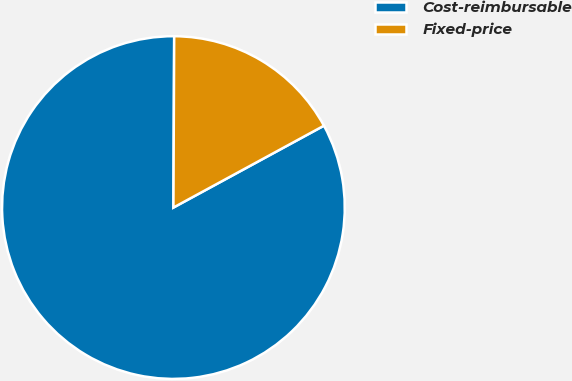<chart> <loc_0><loc_0><loc_500><loc_500><pie_chart><fcel>Cost-reimbursable<fcel>Fixed-price<nl><fcel>83.0%<fcel>17.0%<nl></chart> 